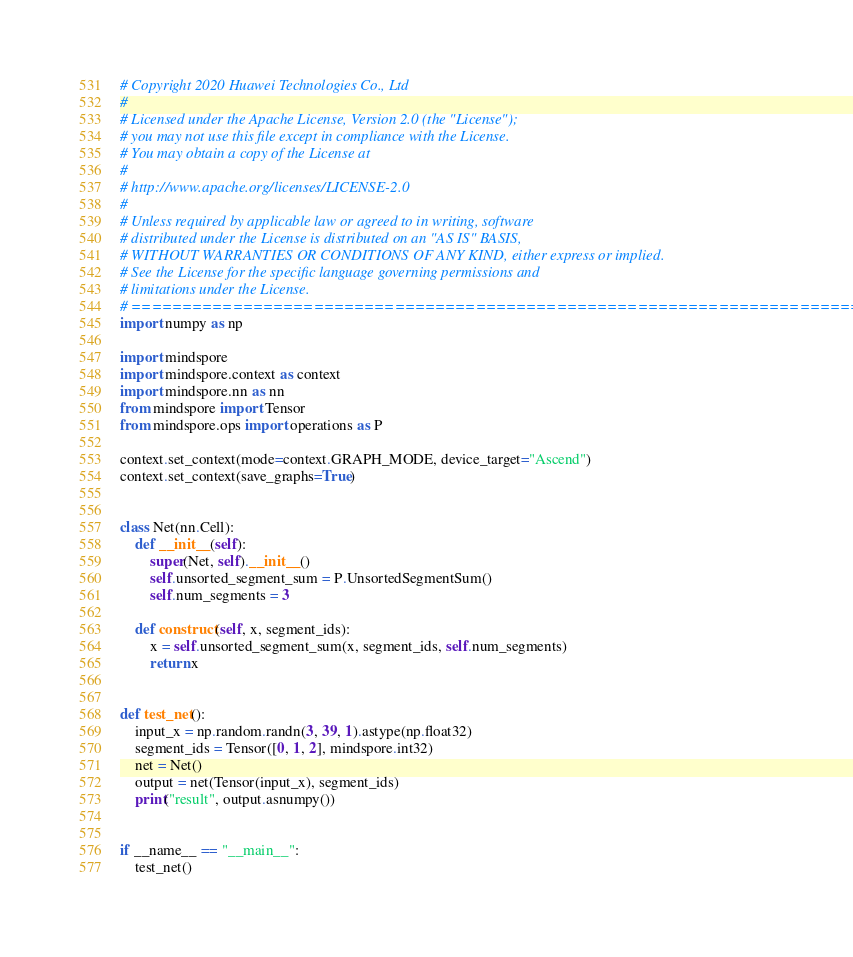Convert code to text. <code><loc_0><loc_0><loc_500><loc_500><_Python_># Copyright 2020 Huawei Technologies Co., Ltd
#
# Licensed under the Apache License, Version 2.0 (the "License");
# you may not use this file except in compliance with the License.
# You may obtain a copy of the License at
#
# http://www.apache.org/licenses/LICENSE-2.0
#
# Unless required by applicable law or agreed to in writing, software
# distributed under the License is distributed on an "AS IS" BASIS,
# WITHOUT WARRANTIES OR CONDITIONS OF ANY KIND, either express or implied.
# See the License for the specific language governing permissions and
# limitations under the License.
# ============================================================================
import numpy as np

import mindspore
import mindspore.context as context
import mindspore.nn as nn
from mindspore import Tensor
from mindspore.ops import operations as P

context.set_context(mode=context.GRAPH_MODE, device_target="Ascend")
context.set_context(save_graphs=True)


class Net(nn.Cell):
    def __init__(self):
        super(Net, self).__init__()
        self.unsorted_segment_sum = P.UnsortedSegmentSum()
        self.num_segments = 3

    def construct(self, x, segment_ids):
        x = self.unsorted_segment_sum(x, segment_ids, self.num_segments)
        return x


def test_net():
    input_x = np.random.randn(3, 39, 1).astype(np.float32)
    segment_ids = Tensor([0, 1, 2], mindspore.int32)
    net = Net()
    output = net(Tensor(input_x), segment_ids)
    print("result", output.asnumpy())


if __name__ == "__main__":
    test_net()
</code> 